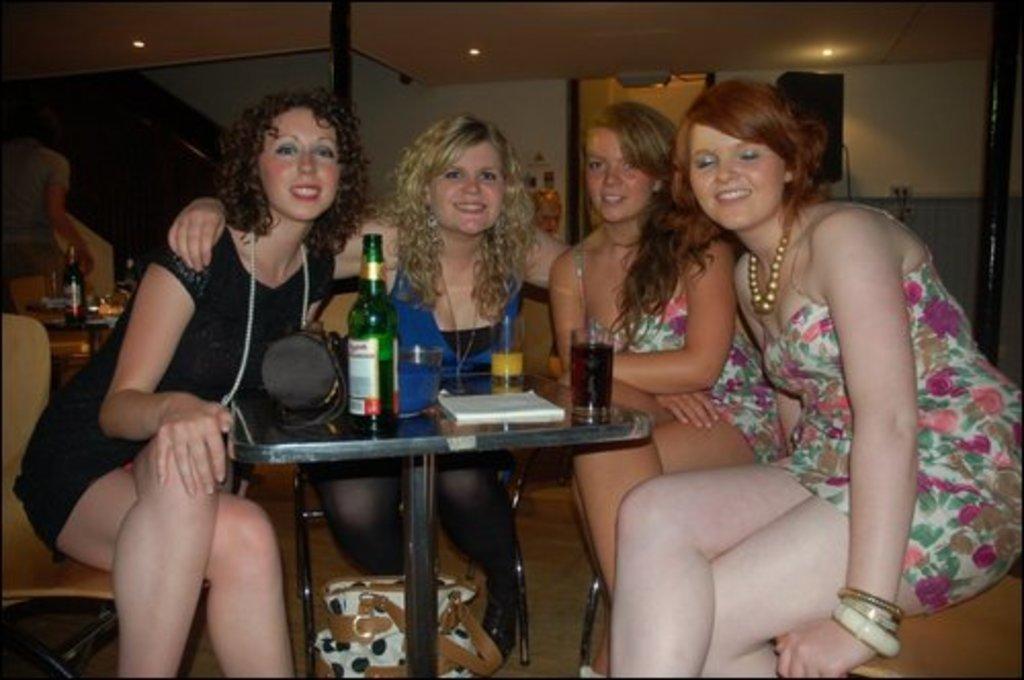Please provide a concise description of this image. In this image I see 4 girls who are sitting on chairs and all of them are smiling, I can also see a table in front of them on which there are glasses, a bottle, a hat and other thing. In the background I see the wall, lights on the ceiling, another bottle over here and another person. 